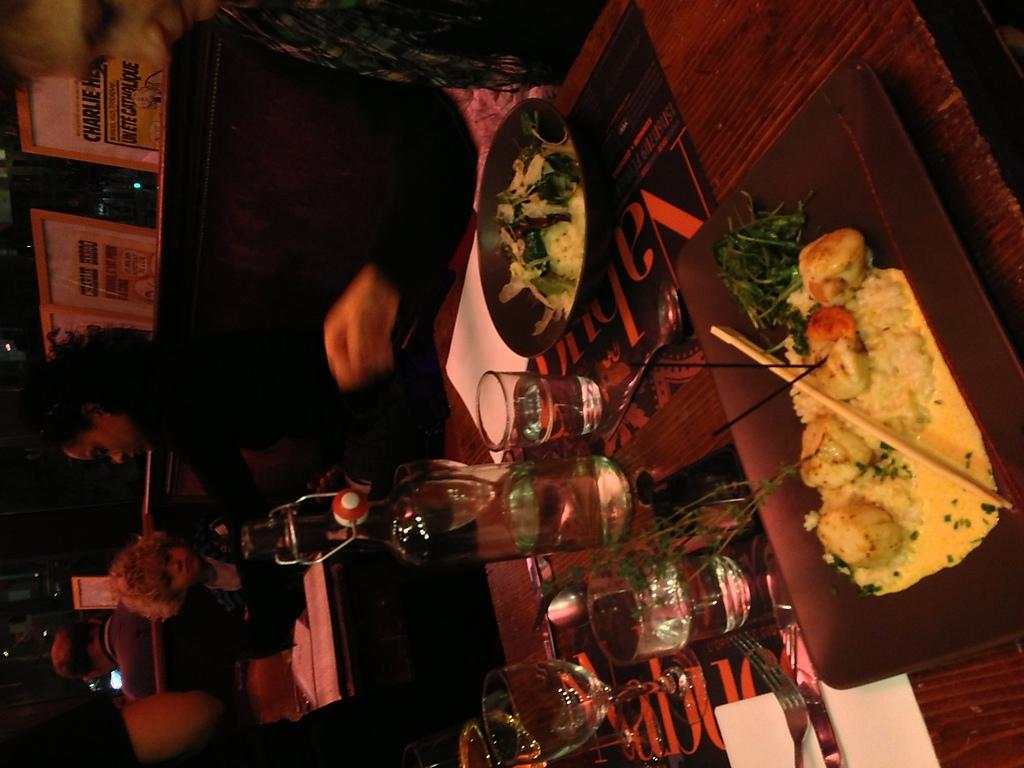What is one item visible in the image that people might use to hold or consume food? There are glasses, chopsticks, a fork, and spoons visible in the image that people might use to hold or consume food. What type of surface is present in the image where food items and utensils might be placed? There is a table in the image where food items and utensils might be placed. What are some food items that can be seen in the image? There are food items visible in the image, but their specific types cannot be determined from the provided facts. What objects might be used for writing or displaying information in the image? There are boards and papers visible in the image that might be used for writing or displaying information. How many people are present in the image? There are people visible in the image, but their exact number cannot be determined from the provided facts. Can you describe the stream that is flowing through the image? There is no stream present in the image; it only contains a table, glasses, food items, plates, chopsticks, a fork, spoons, boards, papers, and people. What thoughts are the people in the image having about the branch? There is no branch or indication of people's thoughts present in the image. 